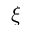Convert formula to latex. <formula><loc_0><loc_0><loc_500><loc_500>\xi</formula> 